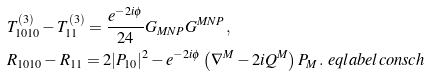<formula> <loc_0><loc_0><loc_500><loc_500>& T ^ { ( 3 ) } _ { 1 0 1 0 } - T ^ { ( 3 ) } _ { 1 1 } = \frac { e ^ { - 2 i \phi } } { 2 4 } G _ { M N P } G ^ { M N P } \, , \\ & R _ { 1 0 1 0 } - R _ { 1 1 } = 2 | P _ { 1 0 } | ^ { 2 } - e ^ { - 2 i \phi } \left ( \nabla ^ { M } - 2 i Q ^ { M } \right ) P _ { M } \, . \ e q l a b e l { c o n s c h }</formula> 